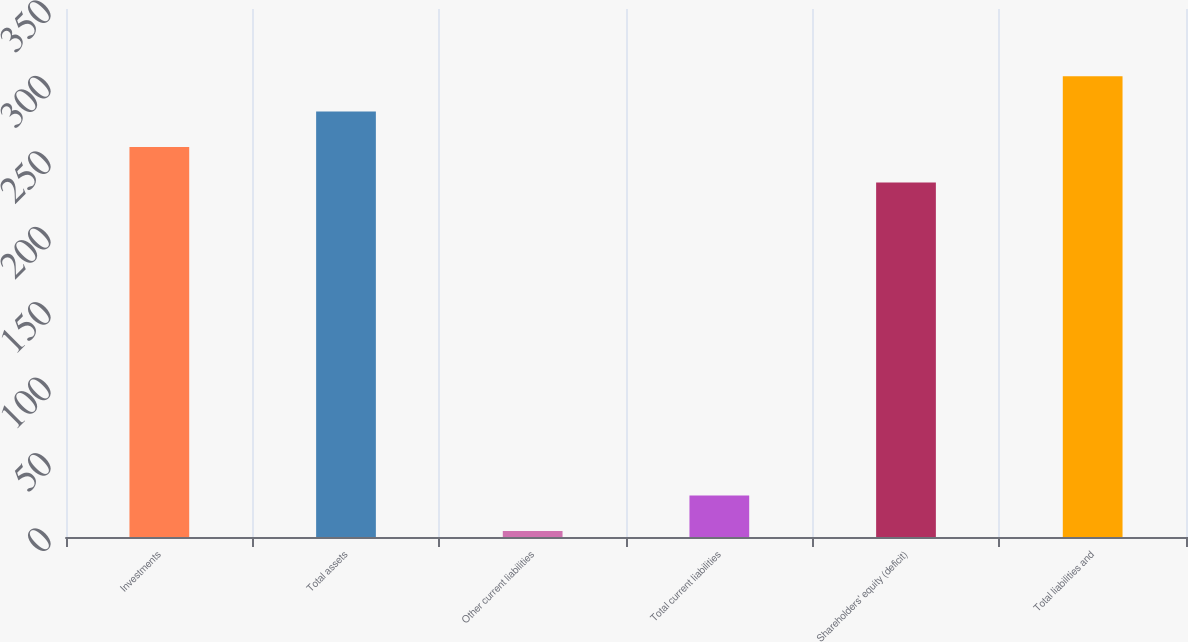Convert chart to OTSL. <chart><loc_0><loc_0><loc_500><loc_500><bar_chart><fcel>Investments<fcel>Total assets<fcel>Other current liabilities<fcel>Total current liabilities<fcel>Shareholders' equity (deficit)<fcel>Total liabilities and<nl><fcel>258.5<fcel>282<fcel>4<fcel>27.5<fcel>235<fcel>305.5<nl></chart> 